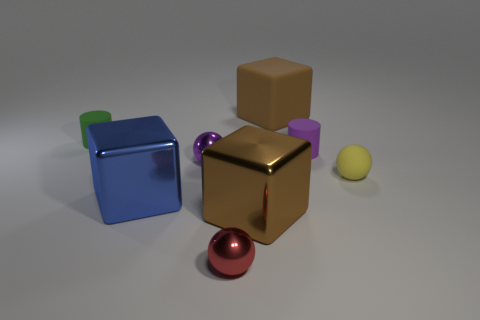How many brown blocks must be subtracted to get 1 brown blocks? 1 Add 2 tiny green metallic balls. How many objects exist? 10 Subtract all metallic balls. How many balls are left? 1 Subtract 1 blue cubes. How many objects are left? 7 Subtract all cylinders. How many objects are left? 6 Subtract 1 cylinders. How many cylinders are left? 1 Subtract all red cylinders. Subtract all cyan blocks. How many cylinders are left? 2 Subtract all gray blocks. How many green cylinders are left? 1 Subtract all blue metal blocks. Subtract all small red balls. How many objects are left? 6 Add 1 purple balls. How many purple balls are left? 2 